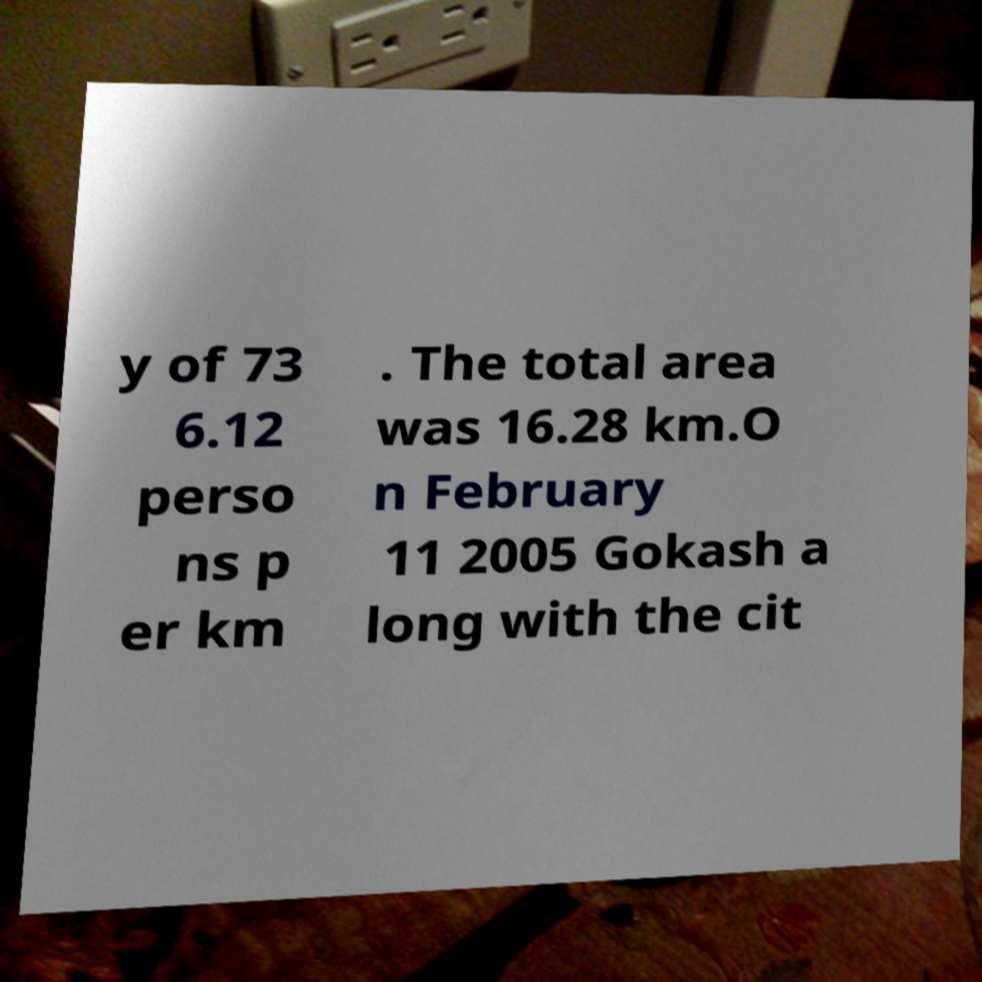For documentation purposes, I need the text within this image transcribed. Could you provide that? y of 73 6.12 perso ns p er km . The total area was 16.28 km.O n February 11 2005 Gokash a long with the cit 